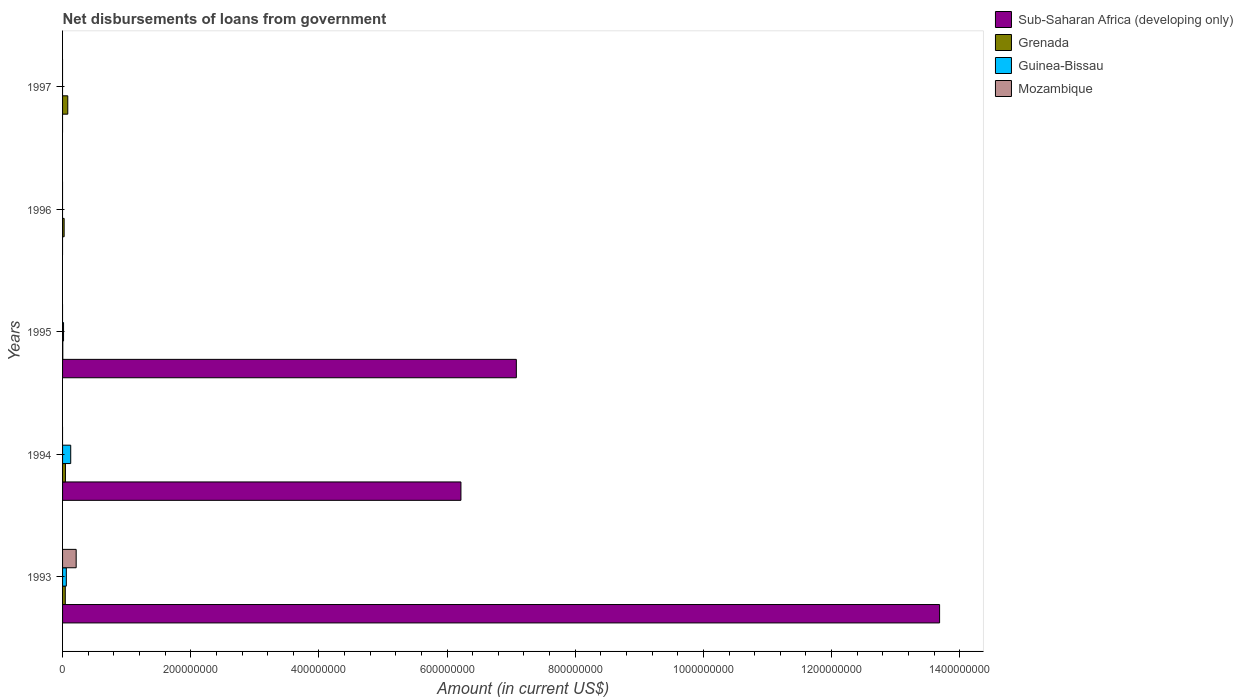How many bars are there on the 5th tick from the top?
Your answer should be very brief. 4. What is the label of the 1st group of bars from the top?
Ensure brevity in your answer.  1997. What is the amount of loan disbursed from government in Sub-Saharan Africa (developing only) in 1994?
Your response must be concise. 6.22e+08. Across all years, what is the maximum amount of loan disbursed from government in Mozambique?
Offer a terse response. 2.12e+07. Across all years, what is the minimum amount of loan disbursed from government in Sub-Saharan Africa (developing only)?
Offer a terse response. 0. In which year was the amount of loan disbursed from government in Mozambique maximum?
Give a very brief answer. 1993. What is the total amount of loan disbursed from government in Mozambique in the graph?
Give a very brief answer. 2.12e+07. What is the difference between the amount of loan disbursed from government in Grenada in 1993 and that in 1995?
Keep it short and to the point. 3.86e+06. What is the difference between the amount of loan disbursed from government in Sub-Saharan Africa (developing only) in 1996 and the amount of loan disbursed from government in Mozambique in 1995?
Keep it short and to the point. 0. What is the average amount of loan disbursed from government in Grenada per year?
Provide a succinct answer. 3.94e+06. In the year 1995, what is the difference between the amount of loan disbursed from government in Sub-Saharan Africa (developing only) and amount of loan disbursed from government in Grenada?
Your response must be concise. 7.08e+08. What is the ratio of the amount of loan disbursed from government in Grenada in 1995 to that in 1996?
Offer a very short reply. 0.15. What is the difference between the highest and the second highest amount of loan disbursed from government in Guinea-Bissau?
Give a very brief answer. 6.84e+06. What is the difference between the highest and the lowest amount of loan disbursed from government in Sub-Saharan Africa (developing only)?
Make the answer very short. 1.37e+09. How many bars are there?
Offer a very short reply. 12. Are all the bars in the graph horizontal?
Offer a terse response. Yes. How many years are there in the graph?
Provide a short and direct response. 5. Are the values on the major ticks of X-axis written in scientific E-notation?
Make the answer very short. No. Does the graph contain any zero values?
Your answer should be compact. Yes. Does the graph contain grids?
Keep it short and to the point. No. How are the legend labels stacked?
Provide a succinct answer. Vertical. What is the title of the graph?
Provide a short and direct response. Net disbursements of loans from government. What is the label or title of the X-axis?
Your answer should be compact. Amount (in current US$). What is the label or title of the Y-axis?
Your answer should be compact. Years. What is the Amount (in current US$) in Sub-Saharan Africa (developing only) in 1993?
Give a very brief answer. 1.37e+09. What is the Amount (in current US$) of Grenada in 1993?
Your response must be concise. 4.22e+06. What is the Amount (in current US$) of Guinea-Bissau in 1993?
Offer a very short reply. 5.87e+06. What is the Amount (in current US$) of Mozambique in 1993?
Keep it short and to the point. 2.12e+07. What is the Amount (in current US$) in Sub-Saharan Africa (developing only) in 1994?
Provide a short and direct response. 6.22e+08. What is the Amount (in current US$) of Grenada in 1994?
Provide a succinct answer. 4.49e+06. What is the Amount (in current US$) of Guinea-Bissau in 1994?
Your answer should be very brief. 1.27e+07. What is the Amount (in current US$) in Mozambique in 1994?
Offer a terse response. 0. What is the Amount (in current US$) of Sub-Saharan Africa (developing only) in 1995?
Offer a very short reply. 7.08e+08. What is the Amount (in current US$) of Grenada in 1995?
Keep it short and to the point. 3.63e+05. What is the Amount (in current US$) in Guinea-Bissau in 1995?
Your answer should be compact. 1.52e+06. What is the Amount (in current US$) of Sub-Saharan Africa (developing only) in 1996?
Your answer should be very brief. 0. What is the Amount (in current US$) of Grenada in 1996?
Provide a succinct answer. 2.47e+06. What is the Amount (in current US$) in Mozambique in 1996?
Give a very brief answer. 0. What is the Amount (in current US$) of Grenada in 1997?
Your answer should be compact. 8.14e+06. What is the Amount (in current US$) in Mozambique in 1997?
Make the answer very short. 0. Across all years, what is the maximum Amount (in current US$) of Sub-Saharan Africa (developing only)?
Provide a succinct answer. 1.37e+09. Across all years, what is the maximum Amount (in current US$) in Grenada?
Provide a short and direct response. 8.14e+06. Across all years, what is the maximum Amount (in current US$) in Guinea-Bissau?
Give a very brief answer. 1.27e+07. Across all years, what is the maximum Amount (in current US$) in Mozambique?
Provide a short and direct response. 2.12e+07. Across all years, what is the minimum Amount (in current US$) of Grenada?
Provide a succinct answer. 3.63e+05. Across all years, what is the minimum Amount (in current US$) of Guinea-Bissau?
Provide a succinct answer. 0. What is the total Amount (in current US$) in Sub-Saharan Africa (developing only) in the graph?
Provide a short and direct response. 2.70e+09. What is the total Amount (in current US$) of Grenada in the graph?
Ensure brevity in your answer.  1.97e+07. What is the total Amount (in current US$) of Guinea-Bissau in the graph?
Provide a short and direct response. 2.01e+07. What is the total Amount (in current US$) of Mozambique in the graph?
Offer a very short reply. 2.12e+07. What is the difference between the Amount (in current US$) in Sub-Saharan Africa (developing only) in 1993 and that in 1994?
Keep it short and to the point. 7.47e+08. What is the difference between the Amount (in current US$) of Grenada in 1993 and that in 1994?
Your answer should be compact. -2.62e+05. What is the difference between the Amount (in current US$) in Guinea-Bissau in 1993 and that in 1994?
Keep it short and to the point. -6.84e+06. What is the difference between the Amount (in current US$) of Sub-Saharan Africa (developing only) in 1993 and that in 1995?
Make the answer very short. 6.60e+08. What is the difference between the Amount (in current US$) in Grenada in 1993 and that in 1995?
Offer a terse response. 3.86e+06. What is the difference between the Amount (in current US$) in Guinea-Bissau in 1993 and that in 1995?
Your response must be concise. 4.35e+06. What is the difference between the Amount (in current US$) of Grenada in 1993 and that in 1996?
Offer a terse response. 1.76e+06. What is the difference between the Amount (in current US$) of Grenada in 1993 and that in 1997?
Your answer should be very brief. -3.92e+06. What is the difference between the Amount (in current US$) in Sub-Saharan Africa (developing only) in 1994 and that in 1995?
Your answer should be compact. -8.65e+07. What is the difference between the Amount (in current US$) in Grenada in 1994 and that in 1995?
Your answer should be very brief. 4.12e+06. What is the difference between the Amount (in current US$) in Guinea-Bissau in 1994 and that in 1995?
Your answer should be very brief. 1.12e+07. What is the difference between the Amount (in current US$) in Grenada in 1994 and that in 1996?
Offer a terse response. 2.02e+06. What is the difference between the Amount (in current US$) in Grenada in 1994 and that in 1997?
Your answer should be compact. -3.66e+06. What is the difference between the Amount (in current US$) in Grenada in 1995 and that in 1996?
Your answer should be compact. -2.11e+06. What is the difference between the Amount (in current US$) of Grenada in 1995 and that in 1997?
Offer a terse response. -7.78e+06. What is the difference between the Amount (in current US$) of Grenada in 1996 and that in 1997?
Provide a succinct answer. -5.67e+06. What is the difference between the Amount (in current US$) in Sub-Saharan Africa (developing only) in 1993 and the Amount (in current US$) in Grenada in 1994?
Your answer should be compact. 1.36e+09. What is the difference between the Amount (in current US$) of Sub-Saharan Africa (developing only) in 1993 and the Amount (in current US$) of Guinea-Bissau in 1994?
Your response must be concise. 1.36e+09. What is the difference between the Amount (in current US$) of Grenada in 1993 and the Amount (in current US$) of Guinea-Bissau in 1994?
Offer a very short reply. -8.48e+06. What is the difference between the Amount (in current US$) in Sub-Saharan Africa (developing only) in 1993 and the Amount (in current US$) in Grenada in 1995?
Provide a succinct answer. 1.37e+09. What is the difference between the Amount (in current US$) of Sub-Saharan Africa (developing only) in 1993 and the Amount (in current US$) of Guinea-Bissau in 1995?
Your answer should be very brief. 1.37e+09. What is the difference between the Amount (in current US$) in Grenada in 1993 and the Amount (in current US$) in Guinea-Bissau in 1995?
Your answer should be very brief. 2.70e+06. What is the difference between the Amount (in current US$) in Sub-Saharan Africa (developing only) in 1993 and the Amount (in current US$) in Grenada in 1996?
Keep it short and to the point. 1.37e+09. What is the difference between the Amount (in current US$) in Sub-Saharan Africa (developing only) in 1993 and the Amount (in current US$) in Grenada in 1997?
Make the answer very short. 1.36e+09. What is the difference between the Amount (in current US$) of Sub-Saharan Africa (developing only) in 1994 and the Amount (in current US$) of Grenada in 1995?
Provide a succinct answer. 6.21e+08. What is the difference between the Amount (in current US$) of Sub-Saharan Africa (developing only) in 1994 and the Amount (in current US$) of Guinea-Bissau in 1995?
Provide a succinct answer. 6.20e+08. What is the difference between the Amount (in current US$) in Grenada in 1994 and the Amount (in current US$) in Guinea-Bissau in 1995?
Your answer should be very brief. 2.96e+06. What is the difference between the Amount (in current US$) in Sub-Saharan Africa (developing only) in 1994 and the Amount (in current US$) in Grenada in 1996?
Provide a short and direct response. 6.19e+08. What is the difference between the Amount (in current US$) of Sub-Saharan Africa (developing only) in 1994 and the Amount (in current US$) of Grenada in 1997?
Make the answer very short. 6.13e+08. What is the difference between the Amount (in current US$) in Sub-Saharan Africa (developing only) in 1995 and the Amount (in current US$) in Grenada in 1996?
Offer a very short reply. 7.06e+08. What is the difference between the Amount (in current US$) in Sub-Saharan Africa (developing only) in 1995 and the Amount (in current US$) in Grenada in 1997?
Make the answer very short. 7.00e+08. What is the average Amount (in current US$) of Sub-Saharan Africa (developing only) per year?
Your response must be concise. 5.40e+08. What is the average Amount (in current US$) of Grenada per year?
Your answer should be compact. 3.94e+06. What is the average Amount (in current US$) of Guinea-Bissau per year?
Your response must be concise. 4.02e+06. What is the average Amount (in current US$) of Mozambique per year?
Your answer should be very brief. 4.25e+06. In the year 1993, what is the difference between the Amount (in current US$) of Sub-Saharan Africa (developing only) and Amount (in current US$) of Grenada?
Provide a short and direct response. 1.36e+09. In the year 1993, what is the difference between the Amount (in current US$) of Sub-Saharan Africa (developing only) and Amount (in current US$) of Guinea-Bissau?
Your response must be concise. 1.36e+09. In the year 1993, what is the difference between the Amount (in current US$) of Sub-Saharan Africa (developing only) and Amount (in current US$) of Mozambique?
Make the answer very short. 1.35e+09. In the year 1993, what is the difference between the Amount (in current US$) in Grenada and Amount (in current US$) in Guinea-Bissau?
Provide a short and direct response. -1.64e+06. In the year 1993, what is the difference between the Amount (in current US$) of Grenada and Amount (in current US$) of Mozambique?
Ensure brevity in your answer.  -1.70e+07. In the year 1993, what is the difference between the Amount (in current US$) in Guinea-Bissau and Amount (in current US$) in Mozambique?
Your answer should be compact. -1.54e+07. In the year 1994, what is the difference between the Amount (in current US$) of Sub-Saharan Africa (developing only) and Amount (in current US$) of Grenada?
Your answer should be very brief. 6.17e+08. In the year 1994, what is the difference between the Amount (in current US$) of Sub-Saharan Africa (developing only) and Amount (in current US$) of Guinea-Bissau?
Offer a very short reply. 6.09e+08. In the year 1994, what is the difference between the Amount (in current US$) in Grenada and Amount (in current US$) in Guinea-Bissau?
Give a very brief answer. -8.22e+06. In the year 1995, what is the difference between the Amount (in current US$) of Sub-Saharan Africa (developing only) and Amount (in current US$) of Grenada?
Offer a very short reply. 7.08e+08. In the year 1995, what is the difference between the Amount (in current US$) of Sub-Saharan Africa (developing only) and Amount (in current US$) of Guinea-Bissau?
Give a very brief answer. 7.07e+08. In the year 1995, what is the difference between the Amount (in current US$) of Grenada and Amount (in current US$) of Guinea-Bissau?
Give a very brief answer. -1.16e+06. What is the ratio of the Amount (in current US$) of Sub-Saharan Africa (developing only) in 1993 to that in 1994?
Your response must be concise. 2.2. What is the ratio of the Amount (in current US$) of Grenada in 1993 to that in 1994?
Provide a succinct answer. 0.94. What is the ratio of the Amount (in current US$) in Guinea-Bissau in 1993 to that in 1994?
Provide a short and direct response. 0.46. What is the ratio of the Amount (in current US$) in Sub-Saharan Africa (developing only) in 1993 to that in 1995?
Provide a short and direct response. 1.93. What is the ratio of the Amount (in current US$) in Grenada in 1993 to that in 1995?
Your answer should be compact. 11.64. What is the ratio of the Amount (in current US$) in Guinea-Bissau in 1993 to that in 1995?
Provide a succinct answer. 3.86. What is the ratio of the Amount (in current US$) of Grenada in 1993 to that in 1996?
Provide a succinct answer. 1.71. What is the ratio of the Amount (in current US$) of Grenada in 1993 to that in 1997?
Make the answer very short. 0.52. What is the ratio of the Amount (in current US$) of Sub-Saharan Africa (developing only) in 1994 to that in 1995?
Your answer should be compact. 0.88. What is the ratio of the Amount (in current US$) of Grenada in 1994 to that in 1995?
Provide a succinct answer. 12.36. What is the ratio of the Amount (in current US$) of Guinea-Bissau in 1994 to that in 1995?
Your response must be concise. 8.35. What is the ratio of the Amount (in current US$) of Grenada in 1994 to that in 1996?
Provide a succinct answer. 1.82. What is the ratio of the Amount (in current US$) of Grenada in 1994 to that in 1997?
Provide a short and direct response. 0.55. What is the ratio of the Amount (in current US$) in Grenada in 1995 to that in 1996?
Keep it short and to the point. 0.15. What is the ratio of the Amount (in current US$) of Grenada in 1995 to that in 1997?
Your answer should be very brief. 0.04. What is the ratio of the Amount (in current US$) of Grenada in 1996 to that in 1997?
Your response must be concise. 0.3. What is the difference between the highest and the second highest Amount (in current US$) of Sub-Saharan Africa (developing only)?
Make the answer very short. 6.60e+08. What is the difference between the highest and the second highest Amount (in current US$) of Grenada?
Offer a very short reply. 3.66e+06. What is the difference between the highest and the second highest Amount (in current US$) of Guinea-Bissau?
Keep it short and to the point. 6.84e+06. What is the difference between the highest and the lowest Amount (in current US$) of Sub-Saharan Africa (developing only)?
Your answer should be very brief. 1.37e+09. What is the difference between the highest and the lowest Amount (in current US$) in Grenada?
Give a very brief answer. 7.78e+06. What is the difference between the highest and the lowest Amount (in current US$) of Guinea-Bissau?
Offer a terse response. 1.27e+07. What is the difference between the highest and the lowest Amount (in current US$) of Mozambique?
Keep it short and to the point. 2.12e+07. 